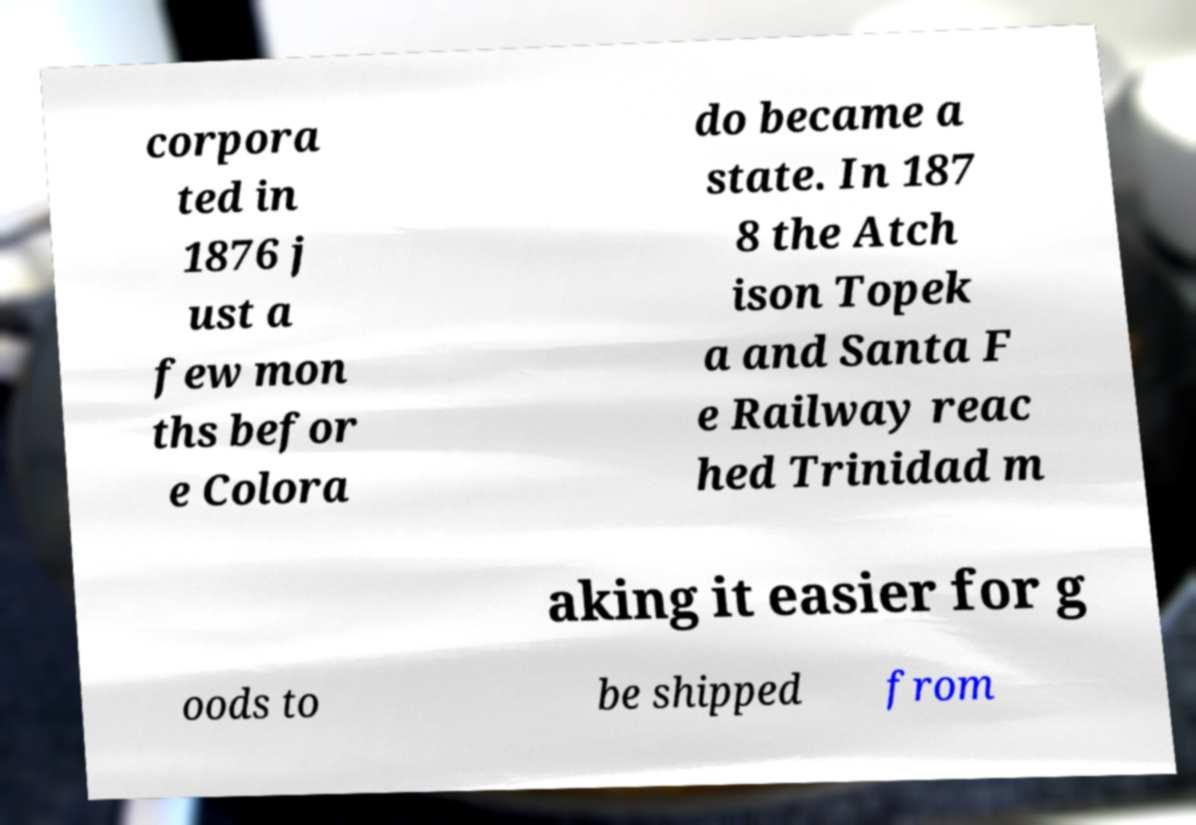Please read and relay the text visible in this image. What does it say? corpora ted in 1876 j ust a few mon ths befor e Colora do became a state. In 187 8 the Atch ison Topek a and Santa F e Railway reac hed Trinidad m aking it easier for g oods to be shipped from 